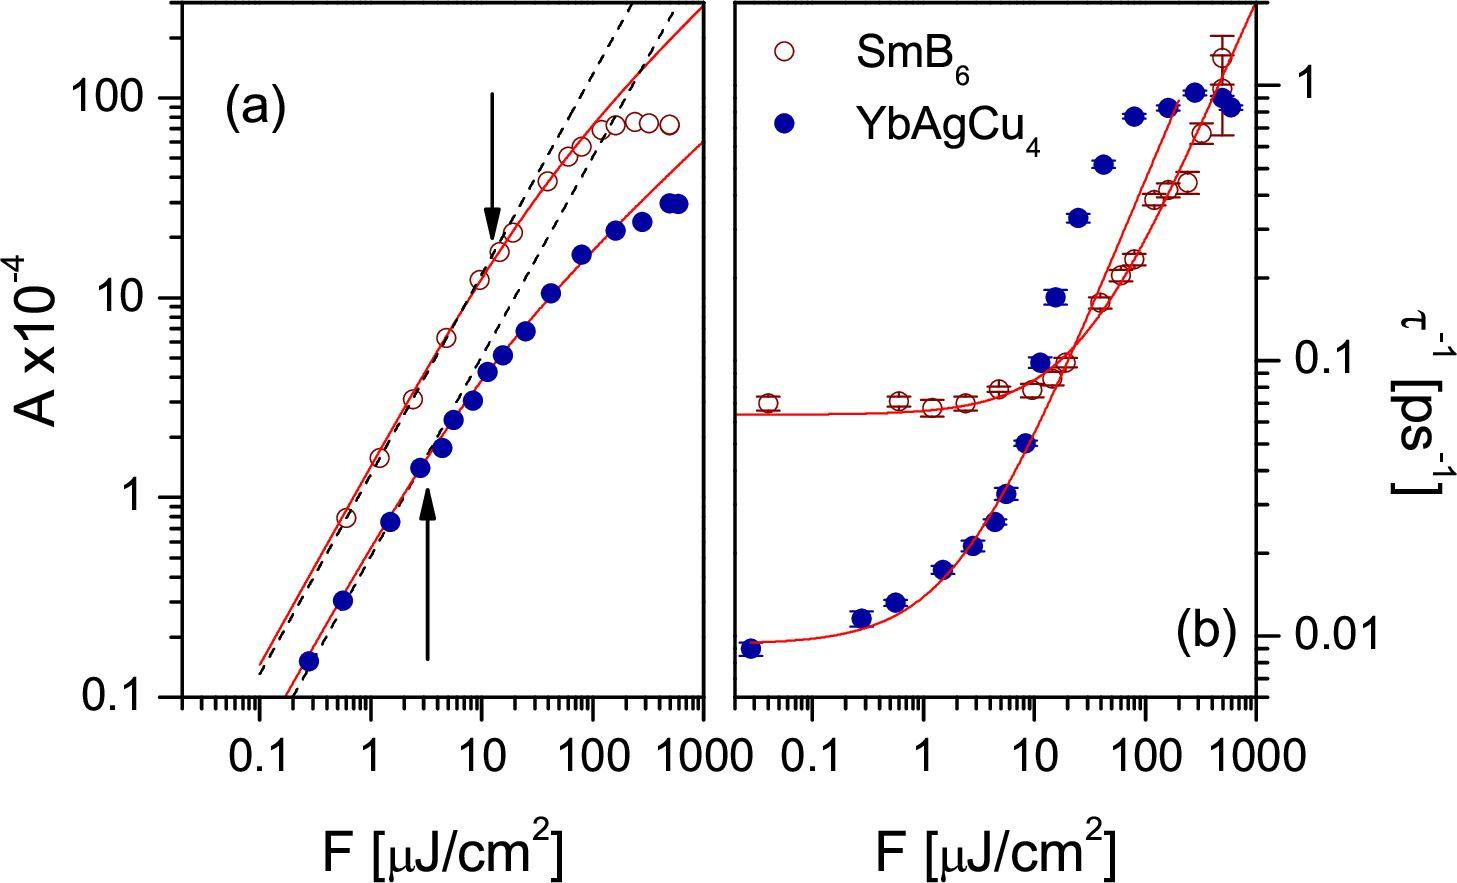What does the arrow in figure (a) most likely indicate about the relationship between 'A' and 'F'? The arrow in figure (a) points to a specific location on the graph, which closely indicates a noticeable change in the slope of the plotted line. This suggests there is a threshold point after which the underlying relationship between 'A' and 'F' changes significantly. The graph up to the threshold shows a consistent trend, but after this point, it appears that 'A' increases or decreases at a different rate relative to 'F'. This could imply a phase transition, critical point, or an operational limit which is crucial in applications involving these variables. 